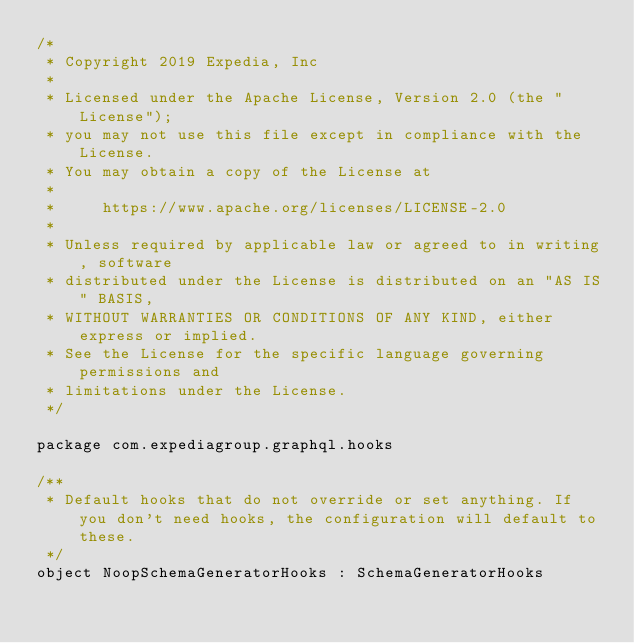Convert code to text. <code><loc_0><loc_0><loc_500><loc_500><_Kotlin_>/*
 * Copyright 2019 Expedia, Inc
 *
 * Licensed under the Apache License, Version 2.0 (the "License");
 * you may not use this file except in compliance with the License.
 * You may obtain a copy of the License at
 *
 *     https://www.apache.org/licenses/LICENSE-2.0
 *
 * Unless required by applicable law or agreed to in writing, software
 * distributed under the License is distributed on an "AS IS" BASIS,
 * WITHOUT WARRANTIES OR CONDITIONS OF ANY KIND, either express or implied.
 * See the License for the specific language governing permissions and
 * limitations under the License.
 */

package com.expediagroup.graphql.hooks

/**
 * Default hooks that do not override or set anything. If you don't need hooks, the configuration will default to these.
 */
object NoopSchemaGeneratorHooks : SchemaGeneratorHooks
</code> 